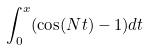Convert formula to latex. <formula><loc_0><loc_0><loc_500><loc_500>\int _ { 0 } ^ { x } ( \cos ( N t ) - 1 ) d t</formula> 